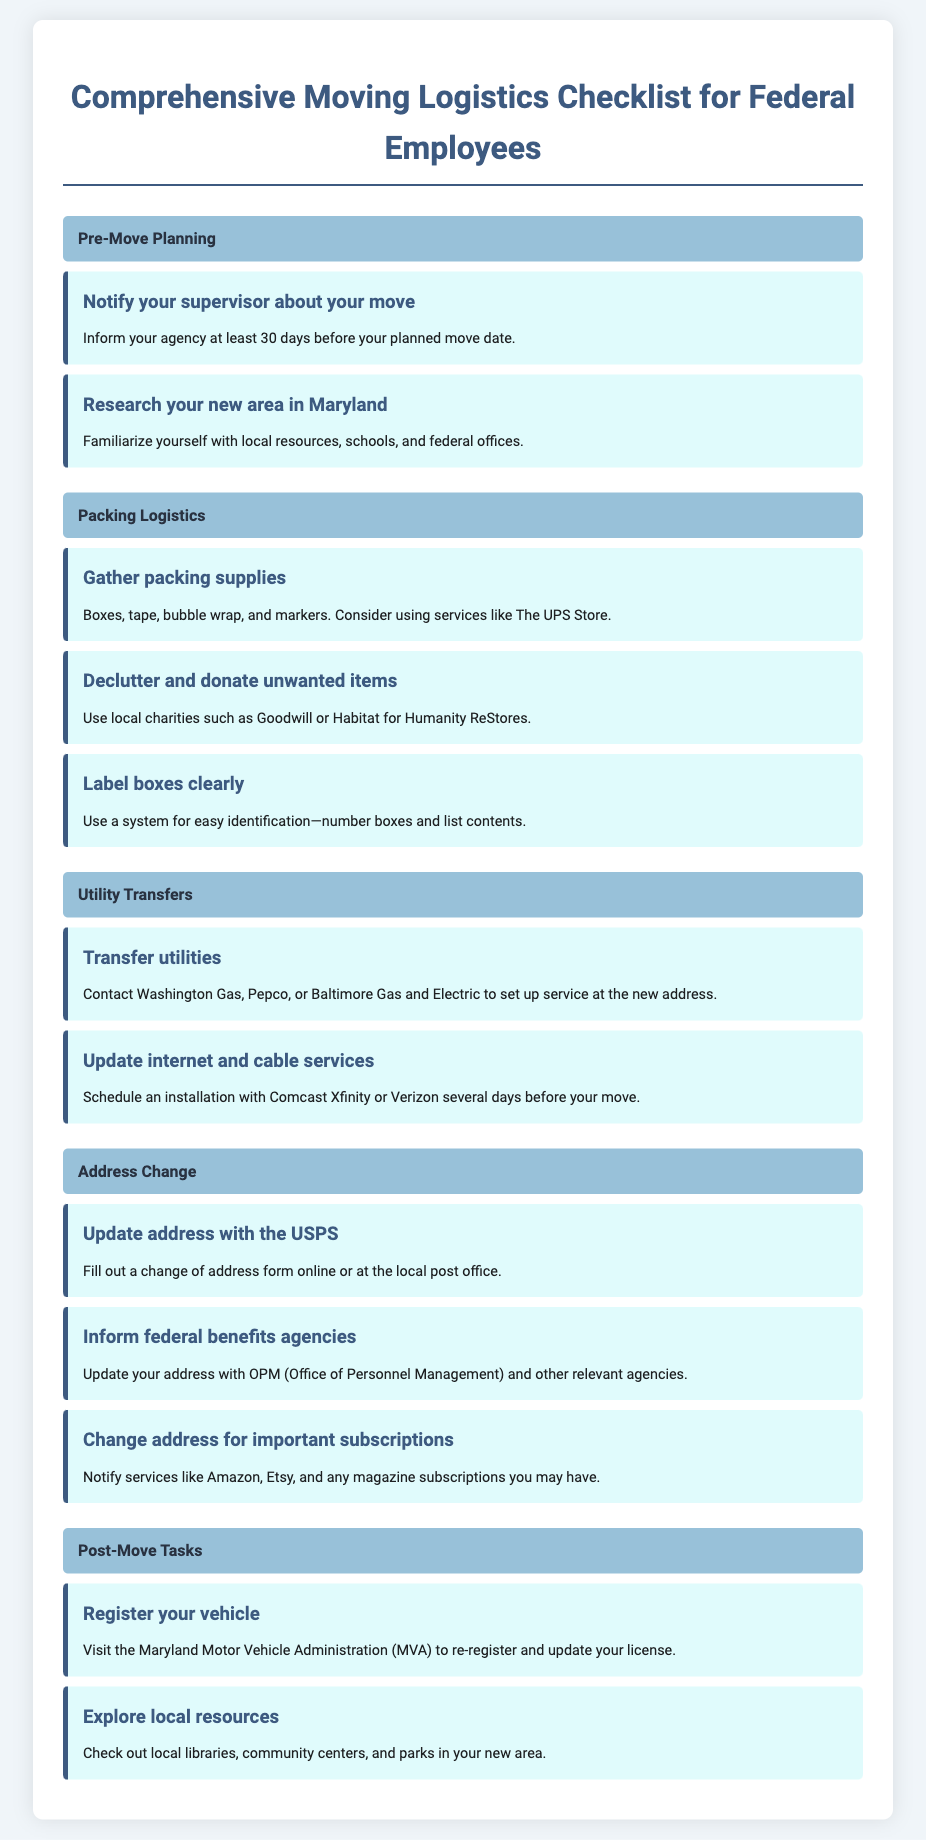what is the title of the document? The title is displayed at the top of the document as part of the header section.
Answer: Comprehensive Moving Logistics Checklist for Federal Employees how many categories are listed in the document? The document features different sections organized by categories.
Answer: 4 what should you do 30 days before your move? The document specifies a task involving notifying your supervisor in advance of the planned move date.
Answer: Notify your supervisor which utility company should you contact to set up service? The document suggests contacting specific utility companies regarding utility transfers.
Answer: Washington Gas what is one important subscription you should notify after your move? The document provides examples of subscriptions that need an address update post-move.
Answer: Amazon what is one action to take during post-move tasks? The document outlines tasks that should be completed after the move, focusing on local administration.
Answer: Register your vehicle what type of supplies should you gather for packing? The document lists essential items required for packing logistics.
Answer: Boxes, tape, bubble wrap who should you inform about your address change? The document identifies an agency that should be notified regarding a change of address.
Answer: OPM (Office of Personnel Management) 